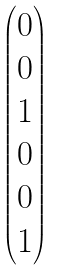<formula> <loc_0><loc_0><loc_500><loc_500>\begin{pmatrix} 0 \\ 0 \\ 1 \\ 0 \\ 0 \\ 1 \end{pmatrix}</formula> 